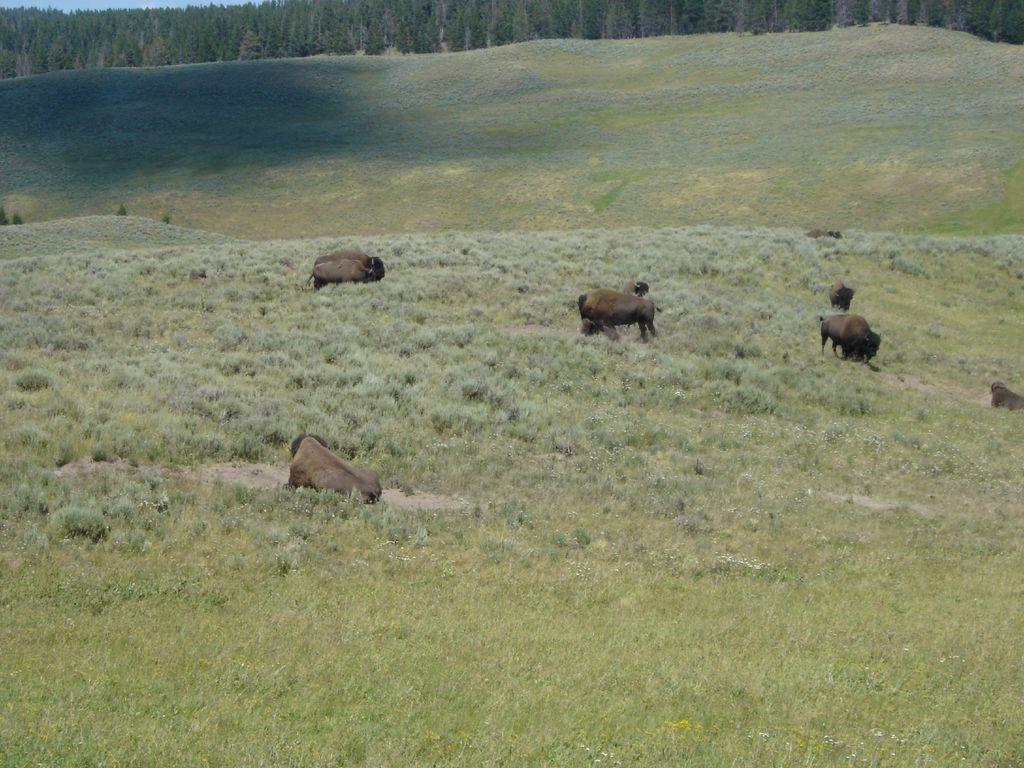Please provide a concise description of this image. In the picture I can see few animals on a greenery ground where one among them is sitting and the remaining are standing and there are trees in the background. 